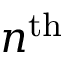Convert formula to latex. <formula><loc_0><loc_0><loc_500><loc_500>n ^ { t h }</formula> 